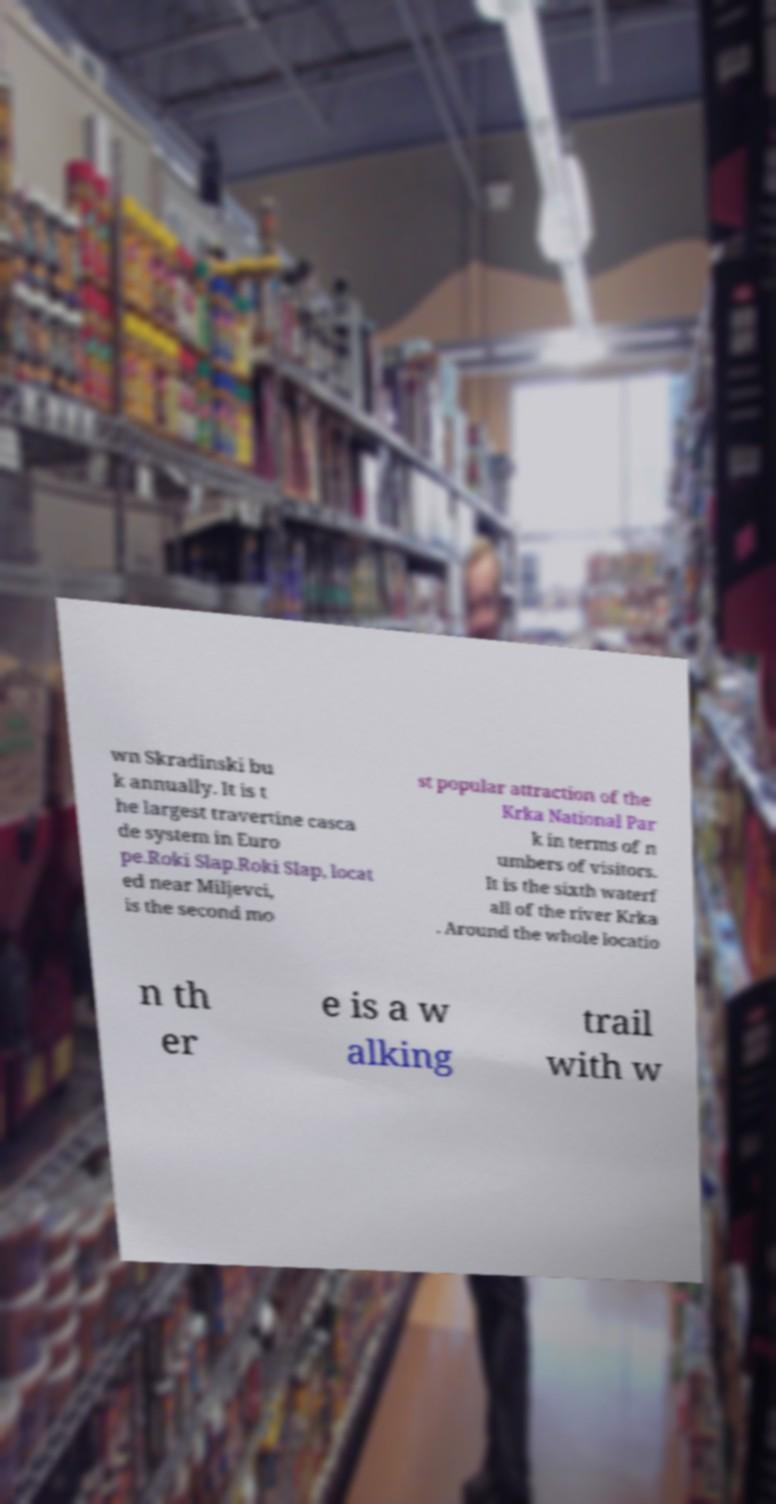Could you extract and type out the text from this image? wn Skradinski bu k annually. It is t he largest travertine casca de system in Euro pe.Roki Slap.Roki Slap, locat ed near Miljevci, is the second mo st popular attraction of the Krka National Par k in terms of n umbers of visitors. It is the sixth waterf all of the river Krka . Around the whole locatio n th er e is a w alking trail with w 